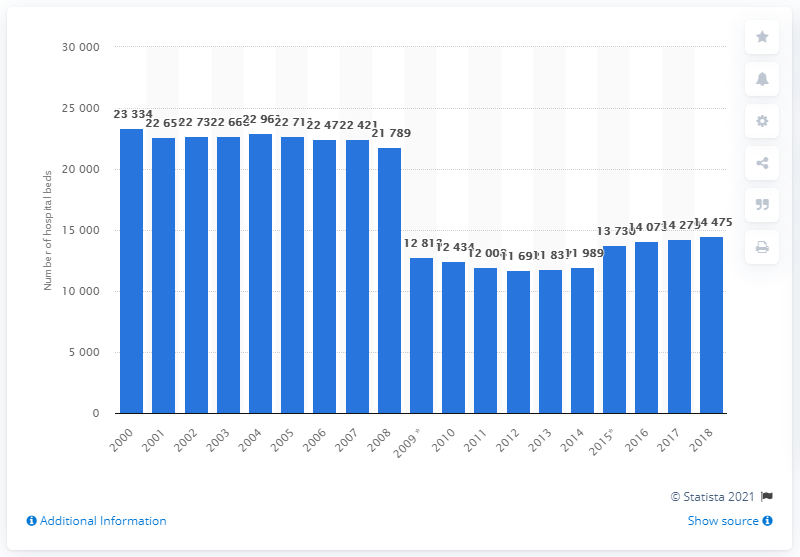Identify some key points in this picture. There were 14,475 hospital beds in Ireland in 2018. 